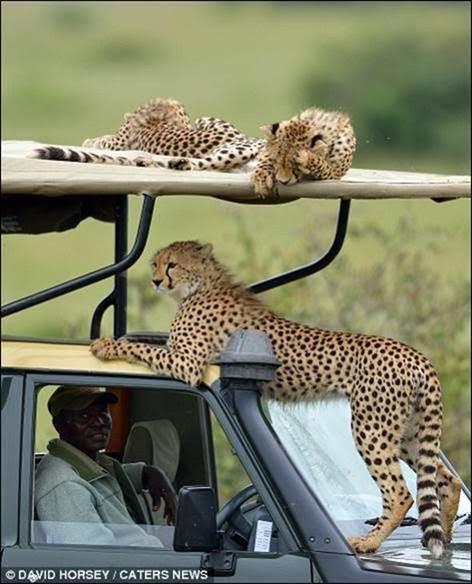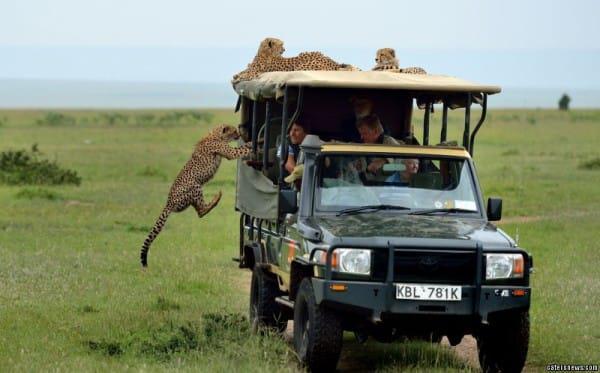The first image is the image on the left, the second image is the image on the right. Examine the images to the left and right. Is the description "In one image, a cheetah is on a seat in the vehicle." accurate? Answer yes or no. No. The first image is the image on the left, the second image is the image on the right. Evaluate the accuracy of this statement regarding the images: "The left image shows a cheetah inside a vehicle perched on the back seat, and the right image shows a cheetah with its body facing the camera, draping its front paws over part of the vehicle's frame.". Is it true? Answer yes or no. No. 